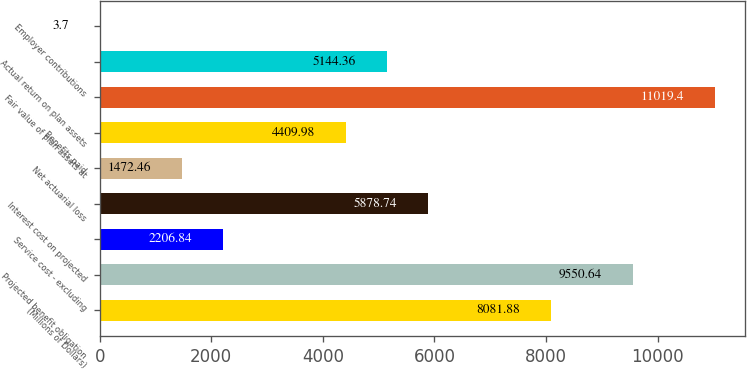<chart> <loc_0><loc_0><loc_500><loc_500><bar_chart><fcel>(Millions of Dollars)<fcel>Projected benefit obligation<fcel>Service cost - excluding<fcel>Interest cost on projected<fcel>Net actuarial loss<fcel>Benefits paid<fcel>Fair value of plan assets at<fcel>Actual return on plan assets<fcel>Employer contributions<nl><fcel>8081.88<fcel>9550.64<fcel>2206.84<fcel>5878.74<fcel>1472.46<fcel>4409.98<fcel>11019.4<fcel>5144.36<fcel>3.7<nl></chart> 